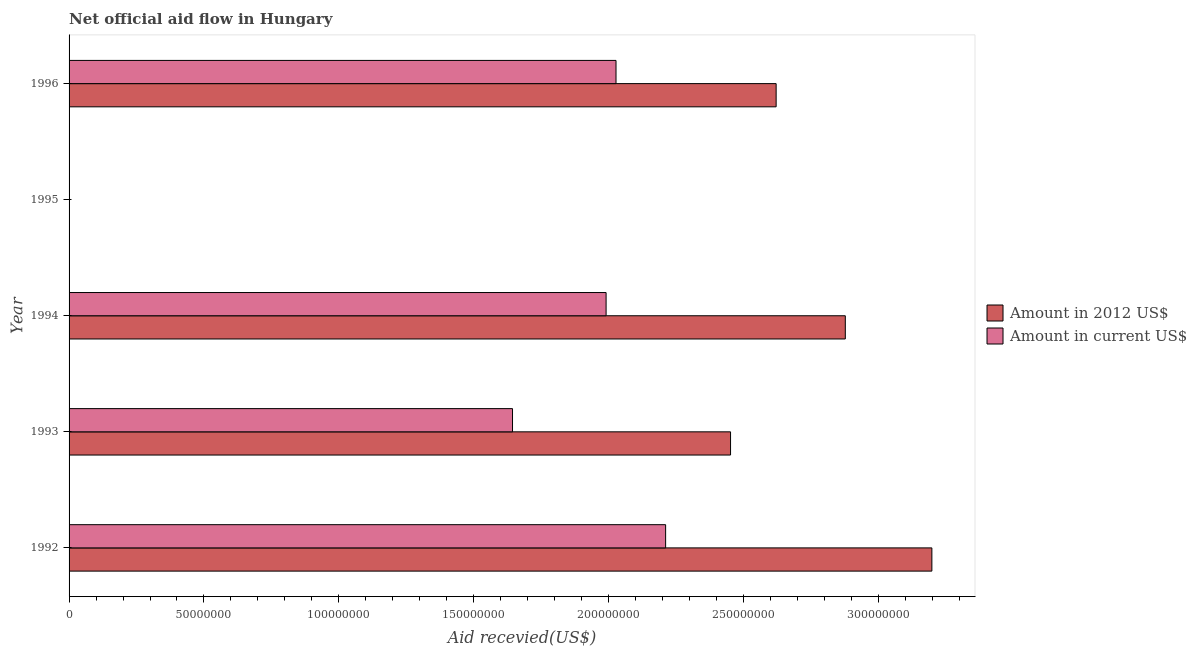Are the number of bars on each tick of the Y-axis equal?
Offer a terse response. No. How many bars are there on the 1st tick from the top?
Keep it short and to the point. 2. What is the label of the 3rd group of bars from the top?
Ensure brevity in your answer.  1994. What is the amount of aid received(expressed in us$) in 1992?
Offer a terse response. 2.21e+08. Across all years, what is the maximum amount of aid received(expressed in 2012 us$)?
Offer a terse response. 3.20e+08. Across all years, what is the minimum amount of aid received(expressed in 2012 us$)?
Provide a succinct answer. 0. What is the total amount of aid received(expressed in 2012 us$) in the graph?
Give a very brief answer. 1.11e+09. What is the difference between the amount of aid received(expressed in 2012 us$) in 1992 and that in 1993?
Keep it short and to the point. 7.46e+07. What is the difference between the amount of aid received(expressed in 2012 us$) in 1992 and the amount of aid received(expressed in us$) in 1993?
Your response must be concise. 1.55e+08. What is the average amount of aid received(expressed in us$) per year?
Provide a short and direct response. 1.57e+08. In the year 1996, what is the difference between the amount of aid received(expressed in 2012 us$) and amount of aid received(expressed in us$)?
Offer a very short reply. 5.94e+07. In how many years, is the amount of aid received(expressed in 2012 us$) greater than 170000000 US$?
Provide a short and direct response. 4. What is the ratio of the amount of aid received(expressed in 2012 us$) in 1992 to that in 1994?
Give a very brief answer. 1.11. What is the difference between the highest and the second highest amount of aid received(expressed in us$)?
Ensure brevity in your answer.  1.84e+07. What is the difference between the highest and the lowest amount of aid received(expressed in 2012 us$)?
Provide a succinct answer. 3.20e+08. What is the difference between two consecutive major ticks on the X-axis?
Offer a very short reply. 5.00e+07. Does the graph contain any zero values?
Ensure brevity in your answer.  Yes. Does the graph contain grids?
Offer a terse response. No. What is the title of the graph?
Offer a very short reply. Net official aid flow in Hungary. Does "Male population" appear as one of the legend labels in the graph?
Offer a very short reply. No. What is the label or title of the X-axis?
Keep it short and to the point. Aid recevied(US$). What is the Aid recevied(US$) in Amount in 2012 US$ in 1992?
Keep it short and to the point. 3.20e+08. What is the Aid recevied(US$) in Amount in current US$ in 1992?
Your answer should be very brief. 2.21e+08. What is the Aid recevied(US$) of Amount in 2012 US$ in 1993?
Offer a terse response. 2.45e+08. What is the Aid recevied(US$) of Amount in current US$ in 1993?
Your response must be concise. 1.64e+08. What is the Aid recevied(US$) in Amount in 2012 US$ in 1994?
Provide a succinct answer. 2.88e+08. What is the Aid recevied(US$) of Amount in current US$ in 1994?
Provide a short and direct response. 1.99e+08. What is the Aid recevied(US$) of Amount in 2012 US$ in 1995?
Keep it short and to the point. 0. What is the Aid recevied(US$) in Amount in 2012 US$ in 1996?
Provide a short and direct response. 2.62e+08. What is the Aid recevied(US$) in Amount in current US$ in 1996?
Your answer should be compact. 2.03e+08. Across all years, what is the maximum Aid recevied(US$) of Amount in 2012 US$?
Keep it short and to the point. 3.20e+08. Across all years, what is the maximum Aid recevied(US$) in Amount in current US$?
Your response must be concise. 2.21e+08. Across all years, what is the minimum Aid recevied(US$) in Amount in 2012 US$?
Offer a very short reply. 0. Across all years, what is the minimum Aid recevied(US$) in Amount in current US$?
Offer a terse response. 0. What is the total Aid recevied(US$) in Amount in 2012 US$ in the graph?
Your answer should be compact. 1.11e+09. What is the total Aid recevied(US$) in Amount in current US$ in the graph?
Provide a short and direct response. 7.87e+08. What is the difference between the Aid recevied(US$) of Amount in 2012 US$ in 1992 and that in 1993?
Your response must be concise. 7.46e+07. What is the difference between the Aid recevied(US$) of Amount in current US$ in 1992 and that in 1993?
Ensure brevity in your answer.  5.68e+07. What is the difference between the Aid recevied(US$) in Amount in 2012 US$ in 1992 and that in 1994?
Provide a short and direct response. 3.21e+07. What is the difference between the Aid recevied(US$) of Amount in current US$ in 1992 and that in 1994?
Your answer should be compact. 2.21e+07. What is the difference between the Aid recevied(US$) in Amount in 2012 US$ in 1992 and that in 1996?
Your answer should be compact. 5.77e+07. What is the difference between the Aid recevied(US$) in Amount in current US$ in 1992 and that in 1996?
Your answer should be compact. 1.84e+07. What is the difference between the Aid recevied(US$) of Amount in 2012 US$ in 1993 and that in 1994?
Keep it short and to the point. -4.25e+07. What is the difference between the Aid recevied(US$) of Amount in current US$ in 1993 and that in 1994?
Give a very brief answer. -3.47e+07. What is the difference between the Aid recevied(US$) of Amount in 2012 US$ in 1993 and that in 1996?
Your answer should be very brief. -1.69e+07. What is the difference between the Aid recevied(US$) in Amount in current US$ in 1993 and that in 1996?
Ensure brevity in your answer.  -3.84e+07. What is the difference between the Aid recevied(US$) in Amount in 2012 US$ in 1994 and that in 1996?
Make the answer very short. 2.56e+07. What is the difference between the Aid recevied(US$) of Amount in current US$ in 1994 and that in 1996?
Your answer should be very brief. -3.68e+06. What is the difference between the Aid recevied(US$) of Amount in 2012 US$ in 1992 and the Aid recevied(US$) of Amount in current US$ in 1993?
Give a very brief answer. 1.55e+08. What is the difference between the Aid recevied(US$) of Amount in 2012 US$ in 1992 and the Aid recevied(US$) of Amount in current US$ in 1994?
Your answer should be very brief. 1.21e+08. What is the difference between the Aid recevied(US$) of Amount in 2012 US$ in 1992 and the Aid recevied(US$) of Amount in current US$ in 1996?
Keep it short and to the point. 1.17e+08. What is the difference between the Aid recevied(US$) of Amount in 2012 US$ in 1993 and the Aid recevied(US$) of Amount in current US$ in 1994?
Provide a succinct answer. 4.61e+07. What is the difference between the Aid recevied(US$) in Amount in 2012 US$ in 1993 and the Aid recevied(US$) in Amount in current US$ in 1996?
Offer a terse response. 4.25e+07. What is the difference between the Aid recevied(US$) of Amount in 2012 US$ in 1994 and the Aid recevied(US$) of Amount in current US$ in 1996?
Give a very brief answer. 8.50e+07. What is the average Aid recevied(US$) of Amount in 2012 US$ per year?
Offer a terse response. 2.23e+08. What is the average Aid recevied(US$) of Amount in current US$ per year?
Your response must be concise. 1.57e+08. In the year 1992, what is the difference between the Aid recevied(US$) in Amount in 2012 US$ and Aid recevied(US$) in Amount in current US$?
Offer a terse response. 9.87e+07. In the year 1993, what is the difference between the Aid recevied(US$) in Amount in 2012 US$ and Aid recevied(US$) in Amount in current US$?
Provide a succinct answer. 8.08e+07. In the year 1994, what is the difference between the Aid recevied(US$) in Amount in 2012 US$ and Aid recevied(US$) in Amount in current US$?
Your answer should be very brief. 8.87e+07. In the year 1996, what is the difference between the Aid recevied(US$) of Amount in 2012 US$ and Aid recevied(US$) of Amount in current US$?
Provide a succinct answer. 5.94e+07. What is the ratio of the Aid recevied(US$) in Amount in 2012 US$ in 1992 to that in 1993?
Your answer should be very brief. 1.3. What is the ratio of the Aid recevied(US$) in Amount in current US$ in 1992 to that in 1993?
Make the answer very short. 1.35. What is the ratio of the Aid recevied(US$) in Amount in 2012 US$ in 1992 to that in 1994?
Your response must be concise. 1.11. What is the ratio of the Aid recevied(US$) in Amount in current US$ in 1992 to that in 1994?
Keep it short and to the point. 1.11. What is the ratio of the Aid recevied(US$) of Amount in 2012 US$ in 1992 to that in 1996?
Offer a very short reply. 1.22. What is the ratio of the Aid recevied(US$) of Amount in current US$ in 1992 to that in 1996?
Give a very brief answer. 1.09. What is the ratio of the Aid recevied(US$) of Amount in 2012 US$ in 1993 to that in 1994?
Provide a short and direct response. 0.85. What is the ratio of the Aid recevied(US$) in Amount in current US$ in 1993 to that in 1994?
Your response must be concise. 0.83. What is the ratio of the Aid recevied(US$) in Amount in 2012 US$ in 1993 to that in 1996?
Your answer should be compact. 0.94. What is the ratio of the Aid recevied(US$) in Amount in current US$ in 1993 to that in 1996?
Make the answer very short. 0.81. What is the ratio of the Aid recevied(US$) in Amount in 2012 US$ in 1994 to that in 1996?
Keep it short and to the point. 1.1. What is the ratio of the Aid recevied(US$) in Amount in current US$ in 1994 to that in 1996?
Make the answer very short. 0.98. What is the difference between the highest and the second highest Aid recevied(US$) in Amount in 2012 US$?
Offer a terse response. 3.21e+07. What is the difference between the highest and the second highest Aid recevied(US$) of Amount in current US$?
Provide a short and direct response. 1.84e+07. What is the difference between the highest and the lowest Aid recevied(US$) in Amount in 2012 US$?
Your answer should be compact. 3.20e+08. What is the difference between the highest and the lowest Aid recevied(US$) in Amount in current US$?
Provide a succinct answer. 2.21e+08. 